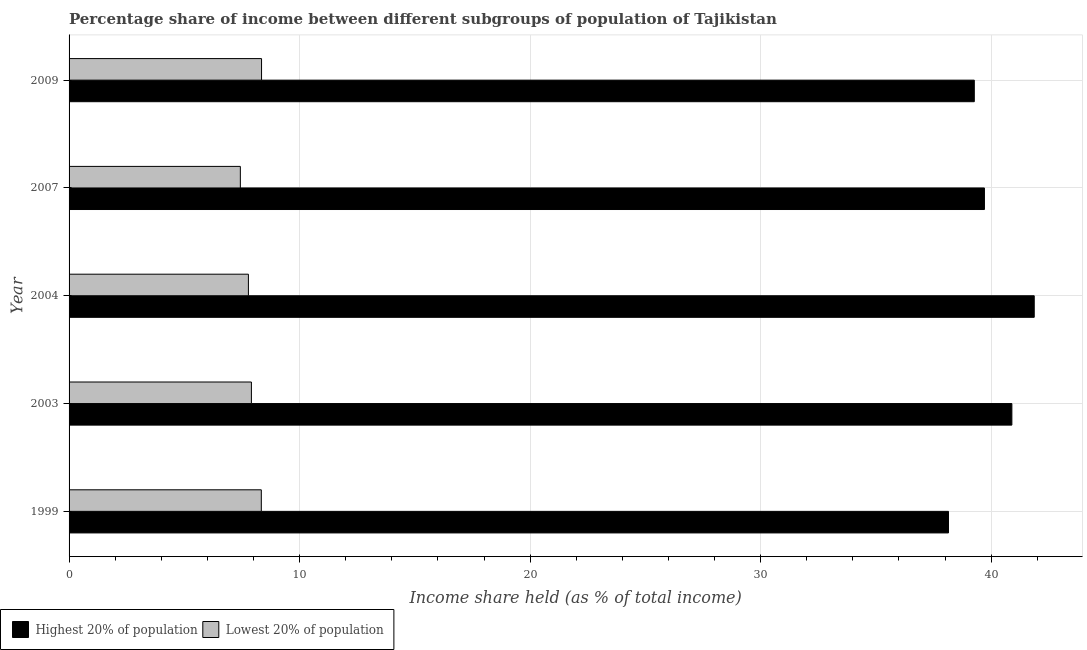How many different coloured bars are there?
Offer a very short reply. 2. Are the number of bars per tick equal to the number of legend labels?
Your answer should be compact. Yes. What is the income share held by highest 20% of the population in 2003?
Offer a very short reply. 40.9. Across all years, what is the maximum income share held by highest 20% of the population?
Your answer should be very brief. 41.87. Across all years, what is the minimum income share held by highest 20% of the population?
Keep it short and to the point. 38.15. In which year was the income share held by lowest 20% of the population maximum?
Make the answer very short. 2009. What is the total income share held by highest 20% of the population in the graph?
Your answer should be very brief. 199.9. What is the difference between the income share held by highest 20% of the population in 2003 and that in 2009?
Your answer should be compact. 1.63. What is the difference between the income share held by lowest 20% of the population in 1999 and the income share held by highest 20% of the population in 2007?
Offer a terse response. -31.37. What is the average income share held by highest 20% of the population per year?
Your answer should be very brief. 39.98. In the year 2007, what is the difference between the income share held by highest 20% of the population and income share held by lowest 20% of the population?
Give a very brief answer. 32.28. In how many years, is the income share held by highest 20% of the population greater than 14 %?
Provide a short and direct response. 5. What is the ratio of the income share held by lowest 20% of the population in 1999 to that in 2003?
Ensure brevity in your answer.  1.05. Is the income share held by highest 20% of the population in 2003 less than that in 2004?
Offer a terse response. Yes. Is the difference between the income share held by lowest 20% of the population in 1999 and 2003 greater than the difference between the income share held by highest 20% of the population in 1999 and 2003?
Offer a terse response. Yes. What is the difference between the highest and the second highest income share held by highest 20% of the population?
Offer a very short reply. 0.97. What is the difference between the highest and the lowest income share held by highest 20% of the population?
Provide a short and direct response. 3.72. Is the sum of the income share held by lowest 20% of the population in 1999 and 2004 greater than the maximum income share held by highest 20% of the population across all years?
Your answer should be very brief. No. What does the 2nd bar from the top in 2003 represents?
Your answer should be very brief. Highest 20% of population. What does the 1st bar from the bottom in 2004 represents?
Ensure brevity in your answer.  Highest 20% of population. Are all the bars in the graph horizontal?
Your answer should be very brief. Yes. How many years are there in the graph?
Provide a short and direct response. 5. What is the difference between two consecutive major ticks on the X-axis?
Make the answer very short. 10. Are the values on the major ticks of X-axis written in scientific E-notation?
Offer a terse response. No. Does the graph contain grids?
Your answer should be compact. Yes. How many legend labels are there?
Provide a succinct answer. 2. How are the legend labels stacked?
Your answer should be very brief. Horizontal. What is the title of the graph?
Keep it short and to the point. Percentage share of income between different subgroups of population of Tajikistan. Does "Imports" appear as one of the legend labels in the graph?
Provide a short and direct response. No. What is the label or title of the X-axis?
Ensure brevity in your answer.  Income share held (as % of total income). What is the Income share held (as % of total income) of Highest 20% of population in 1999?
Your answer should be very brief. 38.15. What is the Income share held (as % of total income) in Lowest 20% of population in 1999?
Ensure brevity in your answer.  8.34. What is the Income share held (as % of total income) in Highest 20% of population in 2003?
Offer a terse response. 40.9. What is the Income share held (as % of total income) of Lowest 20% of population in 2003?
Make the answer very short. 7.91. What is the Income share held (as % of total income) of Highest 20% of population in 2004?
Give a very brief answer. 41.87. What is the Income share held (as % of total income) of Lowest 20% of population in 2004?
Offer a terse response. 7.78. What is the Income share held (as % of total income) in Highest 20% of population in 2007?
Keep it short and to the point. 39.71. What is the Income share held (as % of total income) in Lowest 20% of population in 2007?
Your answer should be very brief. 7.43. What is the Income share held (as % of total income) of Highest 20% of population in 2009?
Provide a succinct answer. 39.27. What is the Income share held (as % of total income) of Lowest 20% of population in 2009?
Offer a terse response. 8.35. Across all years, what is the maximum Income share held (as % of total income) of Highest 20% of population?
Offer a terse response. 41.87. Across all years, what is the maximum Income share held (as % of total income) of Lowest 20% of population?
Keep it short and to the point. 8.35. Across all years, what is the minimum Income share held (as % of total income) in Highest 20% of population?
Your answer should be very brief. 38.15. Across all years, what is the minimum Income share held (as % of total income) of Lowest 20% of population?
Ensure brevity in your answer.  7.43. What is the total Income share held (as % of total income) of Highest 20% of population in the graph?
Make the answer very short. 199.9. What is the total Income share held (as % of total income) of Lowest 20% of population in the graph?
Make the answer very short. 39.81. What is the difference between the Income share held (as % of total income) in Highest 20% of population in 1999 and that in 2003?
Your answer should be very brief. -2.75. What is the difference between the Income share held (as % of total income) in Lowest 20% of population in 1999 and that in 2003?
Your answer should be very brief. 0.43. What is the difference between the Income share held (as % of total income) of Highest 20% of population in 1999 and that in 2004?
Give a very brief answer. -3.72. What is the difference between the Income share held (as % of total income) of Lowest 20% of population in 1999 and that in 2004?
Your answer should be compact. 0.56. What is the difference between the Income share held (as % of total income) of Highest 20% of population in 1999 and that in 2007?
Give a very brief answer. -1.56. What is the difference between the Income share held (as % of total income) of Lowest 20% of population in 1999 and that in 2007?
Offer a very short reply. 0.91. What is the difference between the Income share held (as % of total income) of Highest 20% of population in 1999 and that in 2009?
Offer a terse response. -1.12. What is the difference between the Income share held (as % of total income) in Lowest 20% of population in 1999 and that in 2009?
Your answer should be very brief. -0.01. What is the difference between the Income share held (as % of total income) of Highest 20% of population in 2003 and that in 2004?
Offer a terse response. -0.97. What is the difference between the Income share held (as % of total income) of Lowest 20% of population in 2003 and that in 2004?
Give a very brief answer. 0.13. What is the difference between the Income share held (as % of total income) of Highest 20% of population in 2003 and that in 2007?
Provide a succinct answer. 1.19. What is the difference between the Income share held (as % of total income) of Lowest 20% of population in 2003 and that in 2007?
Give a very brief answer. 0.48. What is the difference between the Income share held (as % of total income) in Highest 20% of population in 2003 and that in 2009?
Provide a short and direct response. 1.63. What is the difference between the Income share held (as % of total income) of Lowest 20% of population in 2003 and that in 2009?
Provide a short and direct response. -0.44. What is the difference between the Income share held (as % of total income) in Highest 20% of population in 2004 and that in 2007?
Keep it short and to the point. 2.16. What is the difference between the Income share held (as % of total income) of Highest 20% of population in 2004 and that in 2009?
Your answer should be very brief. 2.6. What is the difference between the Income share held (as % of total income) in Lowest 20% of population in 2004 and that in 2009?
Provide a short and direct response. -0.57. What is the difference between the Income share held (as % of total income) of Highest 20% of population in 2007 and that in 2009?
Ensure brevity in your answer.  0.44. What is the difference between the Income share held (as % of total income) in Lowest 20% of population in 2007 and that in 2009?
Provide a succinct answer. -0.92. What is the difference between the Income share held (as % of total income) of Highest 20% of population in 1999 and the Income share held (as % of total income) of Lowest 20% of population in 2003?
Make the answer very short. 30.24. What is the difference between the Income share held (as % of total income) of Highest 20% of population in 1999 and the Income share held (as % of total income) of Lowest 20% of population in 2004?
Make the answer very short. 30.37. What is the difference between the Income share held (as % of total income) in Highest 20% of population in 1999 and the Income share held (as % of total income) in Lowest 20% of population in 2007?
Your answer should be very brief. 30.72. What is the difference between the Income share held (as % of total income) in Highest 20% of population in 1999 and the Income share held (as % of total income) in Lowest 20% of population in 2009?
Make the answer very short. 29.8. What is the difference between the Income share held (as % of total income) in Highest 20% of population in 2003 and the Income share held (as % of total income) in Lowest 20% of population in 2004?
Provide a short and direct response. 33.12. What is the difference between the Income share held (as % of total income) of Highest 20% of population in 2003 and the Income share held (as % of total income) of Lowest 20% of population in 2007?
Your answer should be compact. 33.47. What is the difference between the Income share held (as % of total income) of Highest 20% of population in 2003 and the Income share held (as % of total income) of Lowest 20% of population in 2009?
Provide a short and direct response. 32.55. What is the difference between the Income share held (as % of total income) of Highest 20% of population in 2004 and the Income share held (as % of total income) of Lowest 20% of population in 2007?
Make the answer very short. 34.44. What is the difference between the Income share held (as % of total income) of Highest 20% of population in 2004 and the Income share held (as % of total income) of Lowest 20% of population in 2009?
Offer a very short reply. 33.52. What is the difference between the Income share held (as % of total income) in Highest 20% of population in 2007 and the Income share held (as % of total income) in Lowest 20% of population in 2009?
Ensure brevity in your answer.  31.36. What is the average Income share held (as % of total income) in Highest 20% of population per year?
Keep it short and to the point. 39.98. What is the average Income share held (as % of total income) in Lowest 20% of population per year?
Ensure brevity in your answer.  7.96. In the year 1999, what is the difference between the Income share held (as % of total income) of Highest 20% of population and Income share held (as % of total income) of Lowest 20% of population?
Offer a terse response. 29.81. In the year 2003, what is the difference between the Income share held (as % of total income) in Highest 20% of population and Income share held (as % of total income) in Lowest 20% of population?
Offer a very short reply. 32.99. In the year 2004, what is the difference between the Income share held (as % of total income) of Highest 20% of population and Income share held (as % of total income) of Lowest 20% of population?
Keep it short and to the point. 34.09. In the year 2007, what is the difference between the Income share held (as % of total income) of Highest 20% of population and Income share held (as % of total income) of Lowest 20% of population?
Your answer should be very brief. 32.28. In the year 2009, what is the difference between the Income share held (as % of total income) in Highest 20% of population and Income share held (as % of total income) in Lowest 20% of population?
Offer a terse response. 30.92. What is the ratio of the Income share held (as % of total income) of Highest 20% of population in 1999 to that in 2003?
Keep it short and to the point. 0.93. What is the ratio of the Income share held (as % of total income) in Lowest 20% of population in 1999 to that in 2003?
Offer a terse response. 1.05. What is the ratio of the Income share held (as % of total income) in Highest 20% of population in 1999 to that in 2004?
Ensure brevity in your answer.  0.91. What is the ratio of the Income share held (as % of total income) in Lowest 20% of population in 1999 to that in 2004?
Make the answer very short. 1.07. What is the ratio of the Income share held (as % of total income) of Highest 20% of population in 1999 to that in 2007?
Offer a very short reply. 0.96. What is the ratio of the Income share held (as % of total income) in Lowest 20% of population in 1999 to that in 2007?
Provide a short and direct response. 1.12. What is the ratio of the Income share held (as % of total income) in Highest 20% of population in 1999 to that in 2009?
Your answer should be compact. 0.97. What is the ratio of the Income share held (as % of total income) of Lowest 20% of population in 1999 to that in 2009?
Offer a very short reply. 1. What is the ratio of the Income share held (as % of total income) of Highest 20% of population in 2003 to that in 2004?
Your answer should be very brief. 0.98. What is the ratio of the Income share held (as % of total income) of Lowest 20% of population in 2003 to that in 2004?
Your answer should be compact. 1.02. What is the ratio of the Income share held (as % of total income) of Highest 20% of population in 2003 to that in 2007?
Offer a very short reply. 1.03. What is the ratio of the Income share held (as % of total income) in Lowest 20% of population in 2003 to that in 2007?
Give a very brief answer. 1.06. What is the ratio of the Income share held (as % of total income) in Highest 20% of population in 2003 to that in 2009?
Your response must be concise. 1.04. What is the ratio of the Income share held (as % of total income) of Lowest 20% of population in 2003 to that in 2009?
Make the answer very short. 0.95. What is the ratio of the Income share held (as % of total income) in Highest 20% of population in 2004 to that in 2007?
Your response must be concise. 1.05. What is the ratio of the Income share held (as % of total income) of Lowest 20% of population in 2004 to that in 2007?
Ensure brevity in your answer.  1.05. What is the ratio of the Income share held (as % of total income) of Highest 20% of population in 2004 to that in 2009?
Provide a short and direct response. 1.07. What is the ratio of the Income share held (as % of total income) in Lowest 20% of population in 2004 to that in 2009?
Keep it short and to the point. 0.93. What is the ratio of the Income share held (as % of total income) in Highest 20% of population in 2007 to that in 2009?
Provide a succinct answer. 1.01. What is the ratio of the Income share held (as % of total income) of Lowest 20% of population in 2007 to that in 2009?
Keep it short and to the point. 0.89. What is the difference between the highest and the second highest Income share held (as % of total income) of Lowest 20% of population?
Offer a terse response. 0.01. What is the difference between the highest and the lowest Income share held (as % of total income) of Highest 20% of population?
Offer a very short reply. 3.72. 